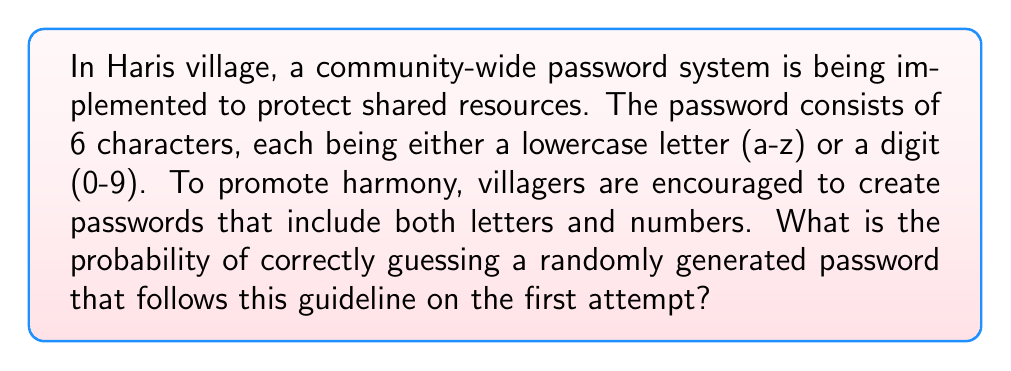Could you help me with this problem? Let's approach this step-by-step:

1) First, we need to calculate the total number of possible characters:
   - 26 lowercase letters
   - 10 digits
   Total: 26 + 10 = 36 possible characters

2) The password is 6 characters long, and we want at least one letter and one digit.

3) To calculate this, we'll use the complement method:
   (Total possibilities) - (Passwords with only letters) - (Passwords with only digits)

4) Total possibilities: $36^6$

5) Passwords with only letters: $26^6$

6) Passwords with only digits: $10^6$

7) Therefore, the number of valid passwords is:
   $36^6 - 26^6 - 10^6$

8) The probability of guessing correctly is:
   $$P(\text{correct guess}) = \frac{1}{\text{number of valid passwords}}$$

9) Substituting the values:
   $$P(\text{correct guess}) = \frac{1}{36^6 - 26^6 - 10^6}$$

10) Calculating:
    $$P(\text{correct guess}) = \frac{1}{2,176,782,336 - 308,915,776 - 1,000,000}$$
    $$= \frac{1}{1,866,866,560}$$
Answer: $\frac{1}{1,866,866,560}$ 